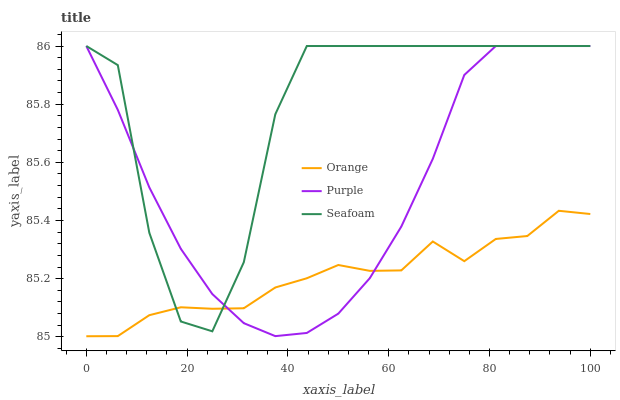Does Orange have the minimum area under the curve?
Answer yes or no. Yes. Does Seafoam have the maximum area under the curve?
Answer yes or no. Yes. Does Purple have the minimum area under the curve?
Answer yes or no. No. Does Purple have the maximum area under the curve?
Answer yes or no. No. Is Purple the smoothest?
Answer yes or no. Yes. Is Seafoam the roughest?
Answer yes or no. Yes. Is Seafoam the smoothest?
Answer yes or no. No. Is Purple the roughest?
Answer yes or no. No. Does Orange have the lowest value?
Answer yes or no. Yes. Does Purple have the lowest value?
Answer yes or no. No. Does Seafoam have the highest value?
Answer yes or no. Yes. Does Orange intersect Purple?
Answer yes or no. Yes. Is Orange less than Purple?
Answer yes or no. No. Is Orange greater than Purple?
Answer yes or no. No. 